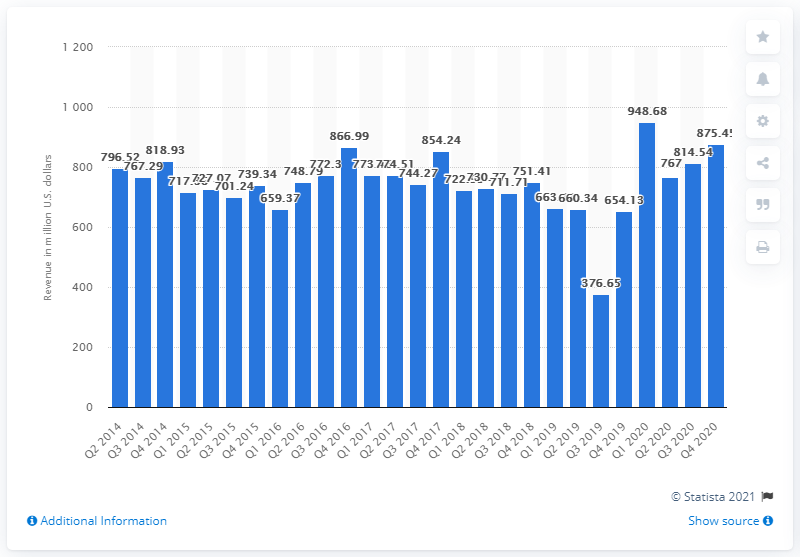Identify some key points in this picture. Gannett Company's revenue in the fourth quarter of 2020 was 875.45 million. In the fourth quarter of 2020, Gannett's revenue was 654.13 million. 